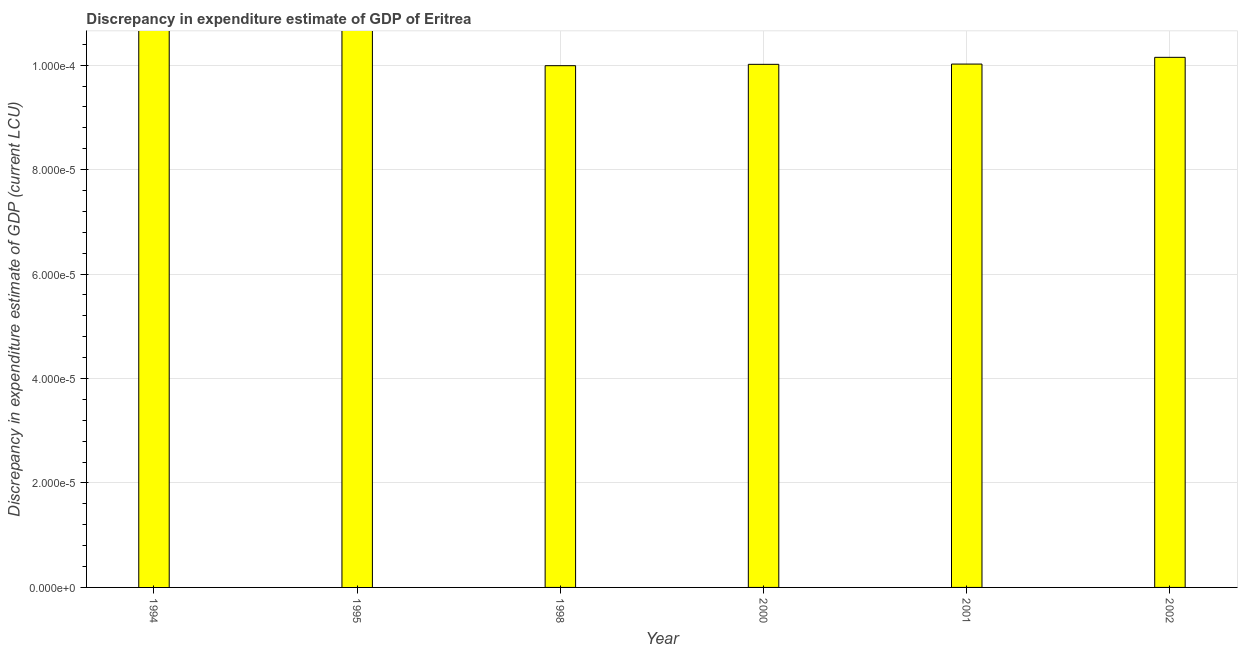Does the graph contain grids?
Your answer should be compact. Yes. What is the title of the graph?
Offer a terse response. Discrepancy in expenditure estimate of GDP of Eritrea. What is the label or title of the X-axis?
Your answer should be very brief. Year. What is the label or title of the Y-axis?
Your answer should be very brief. Discrepancy in expenditure estimate of GDP (current LCU). What is the discrepancy in expenditure estimate of gdp in 2002?
Provide a short and direct response. 0. Across all years, what is the maximum discrepancy in expenditure estimate of gdp?
Offer a very short reply. 0. What is the sum of the discrepancy in expenditure estimate of gdp?
Your response must be concise. 0. What is the difference between the discrepancy in expenditure estimate of gdp in 1998 and 2000?
Keep it short and to the point. -0. What is the average discrepancy in expenditure estimate of gdp per year?
Make the answer very short. 0. What is the median discrepancy in expenditure estimate of gdp?
Keep it short and to the point. 0. In how many years, is the discrepancy in expenditure estimate of gdp greater than 5.2e-05 LCU?
Your answer should be compact. 4. What is the ratio of the discrepancy in expenditure estimate of gdp in 1998 to that in 2002?
Ensure brevity in your answer.  0.98. Is the discrepancy in expenditure estimate of gdp in 2001 less than that in 2002?
Offer a terse response. Yes. Is the difference between the discrepancy in expenditure estimate of gdp in 2000 and 2001 greater than the difference between any two years?
Offer a terse response. No. What is the difference between the highest and the second highest discrepancy in expenditure estimate of gdp?
Provide a short and direct response. 0. Is the sum of the discrepancy in expenditure estimate of gdp in 1998 and 2000 greater than the maximum discrepancy in expenditure estimate of gdp across all years?
Offer a very short reply. Yes. In how many years, is the discrepancy in expenditure estimate of gdp greater than the average discrepancy in expenditure estimate of gdp taken over all years?
Your answer should be compact. 4. How many bars are there?
Provide a short and direct response. 4. How many years are there in the graph?
Offer a very short reply. 6. What is the difference between two consecutive major ticks on the Y-axis?
Ensure brevity in your answer.  2e-5. What is the Discrepancy in expenditure estimate of GDP (current LCU) in 1995?
Your answer should be compact. 0. What is the Discrepancy in expenditure estimate of GDP (current LCU) in 1998?
Offer a terse response. 9.990000000000003e-5. What is the Discrepancy in expenditure estimate of GDP (current LCU) in 2000?
Keep it short and to the point. 0. What is the Discrepancy in expenditure estimate of GDP (current LCU) of 2001?
Make the answer very short. 0. What is the Discrepancy in expenditure estimate of GDP (current LCU) of 2002?
Offer a very short reply. 0. What is the difference between the Discrepancy in expenditure estimate of GDP (current LCU) in 1998 and 2001?
Your answer should be very brief. -0. What is the difference between the Discrepancy in expenditure estimate of GDP (current LCU) in 1998 and 2002?
Ensure brevity in your answer.  -0. What is the difference between the Discrepancy in expenditure estimate of GDP (current LCU) in 2000 and 2001?
Your answer should be compact. -0. What is the difference between the Discrepancy in expenditure estimate of GDP (current LCU) in 2001 and 2002?
Provide a short and direct response. -0. What is the ratio of the Discrepancy in expenditure estimate of GDP (current LCU) in 2000 to that in 2001?
Keep it short and to the point. 1. What is the ratio of the Discrepancy in expenditure estimate of GDP (current LCU) in 2000 to that in 2002?
Ensure brevity in your answer.  0.99. 